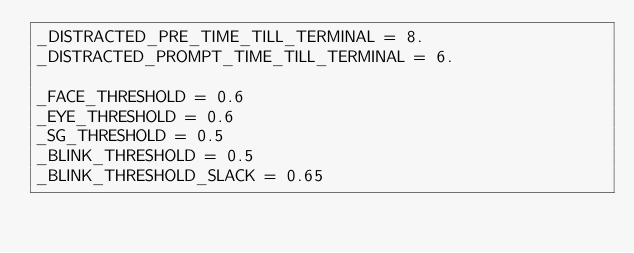<code> <loc_0><loc_0><loc_500><loc_500><_Python_>_DISTRACTED_PRE_TIME_TILL_TERMINAL = 8.
_DISTRACTED_PROMPT_TIME_TILL_TERMINAL = 6.

_FACE_THRESHOLD = 0.6
_EYE_THRESHOLD = 0.6
_SG_THRESHOLD = 0.5
_BLINK_THRESHOLD = 0.5
_BLINK_THRESHOLD_SLACK = 0.65</code> 